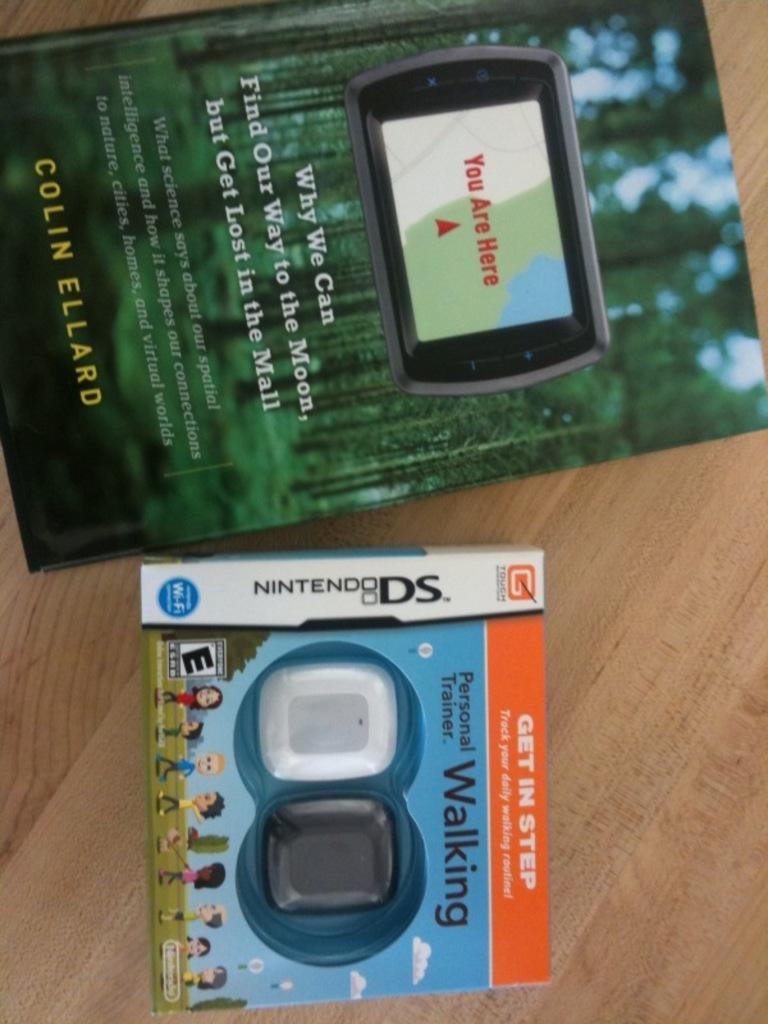<image>
Give a short and clear explanation of the subsequent image. A book and a Nintendo DS personal trainer lay on a wooden surface. 